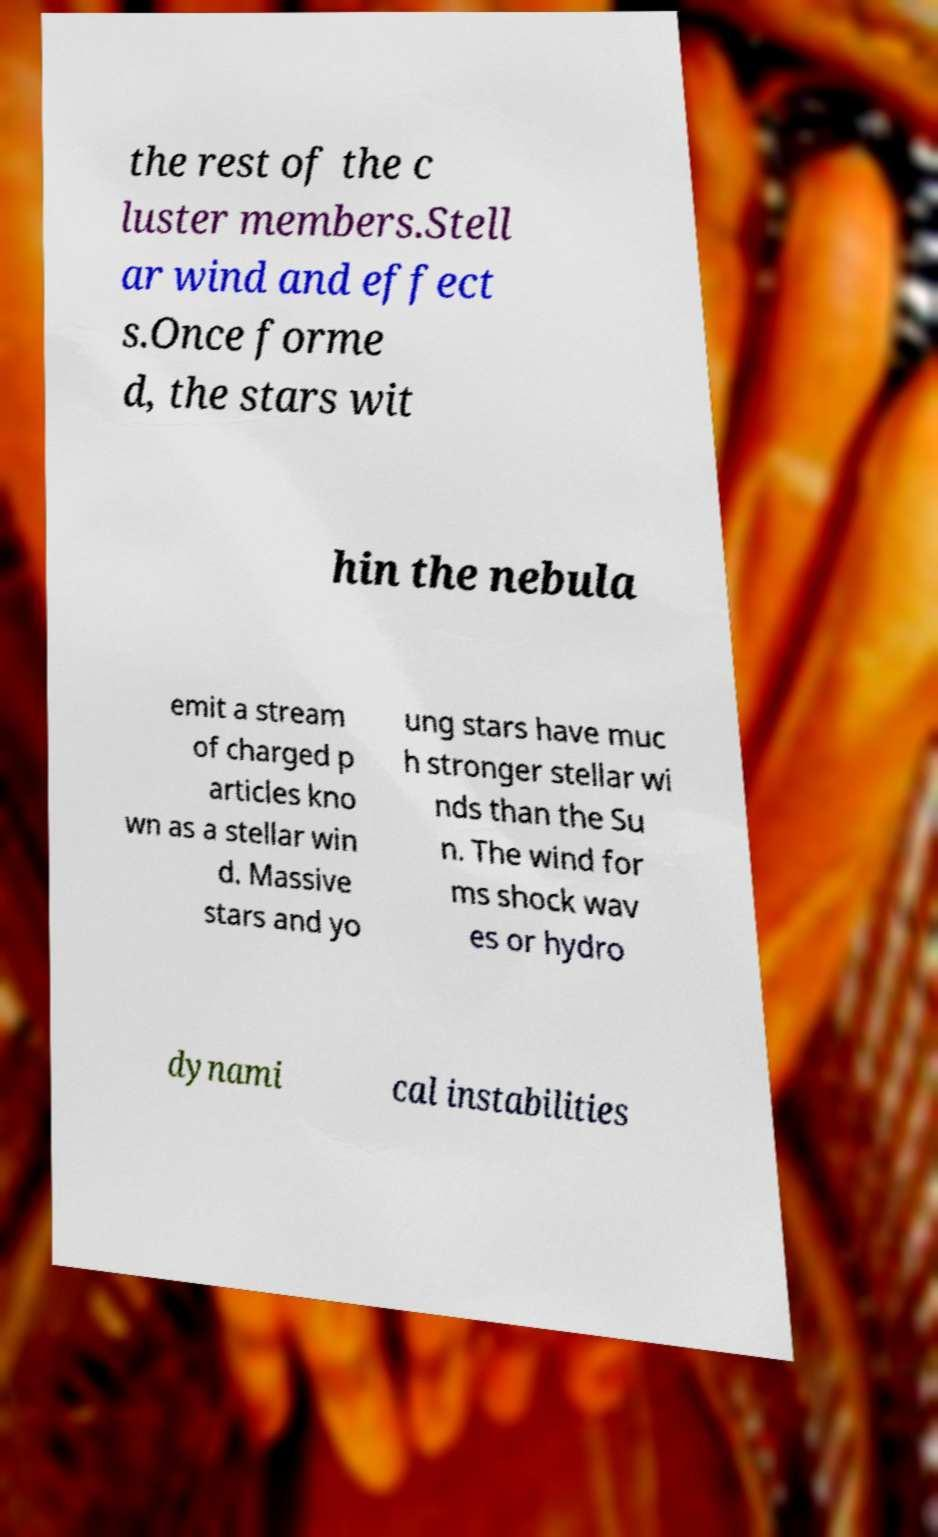There's text embedded in this image that I need extracted. Can you transcribe it verbatim? the rest of the c luster members.Stell ar wind and effect s.Once forme d, the stars wit hin the nebula emit a stream of charged p articles kno wn as a stellar win d. Massive stars and yo ung stars have muc h stronger stellar wi nds than the Su n. The wind for ms shock wav es or hydro dynami cal instabilities 